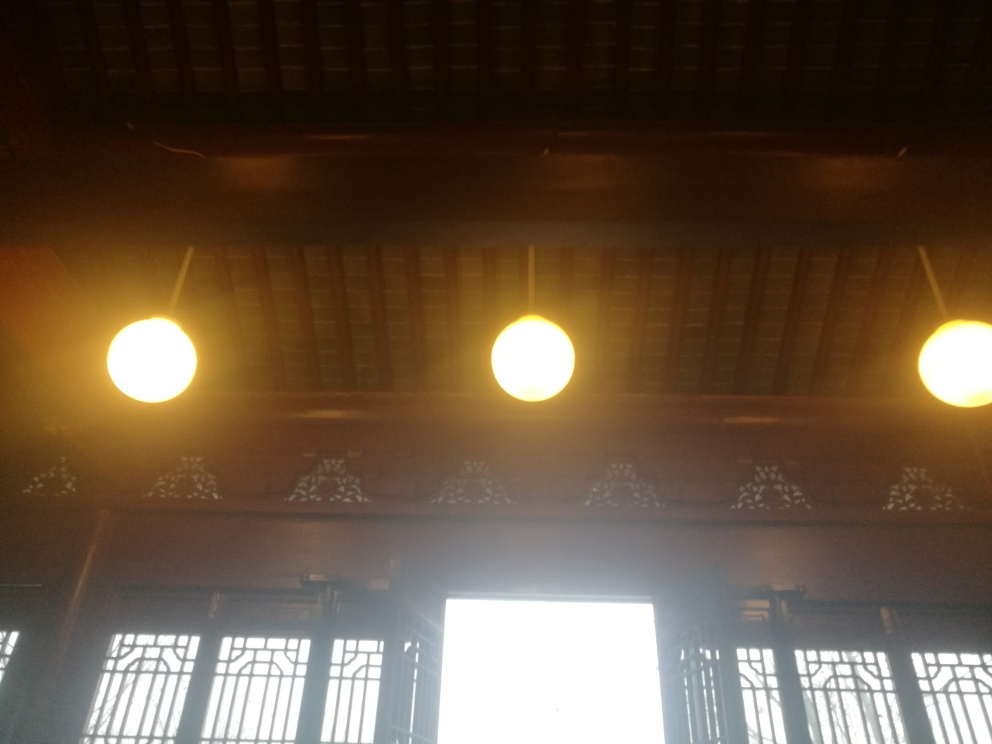What time of day do you think this photo was taken? How can you tell? Given the brightness visible through the window and the artificial lighting inside, it seems that the photo was taken during the day but in a relatively shaded or interior space. The bright light suggests outdoor luminance is high, likely around midday when the sun is at its peak. 